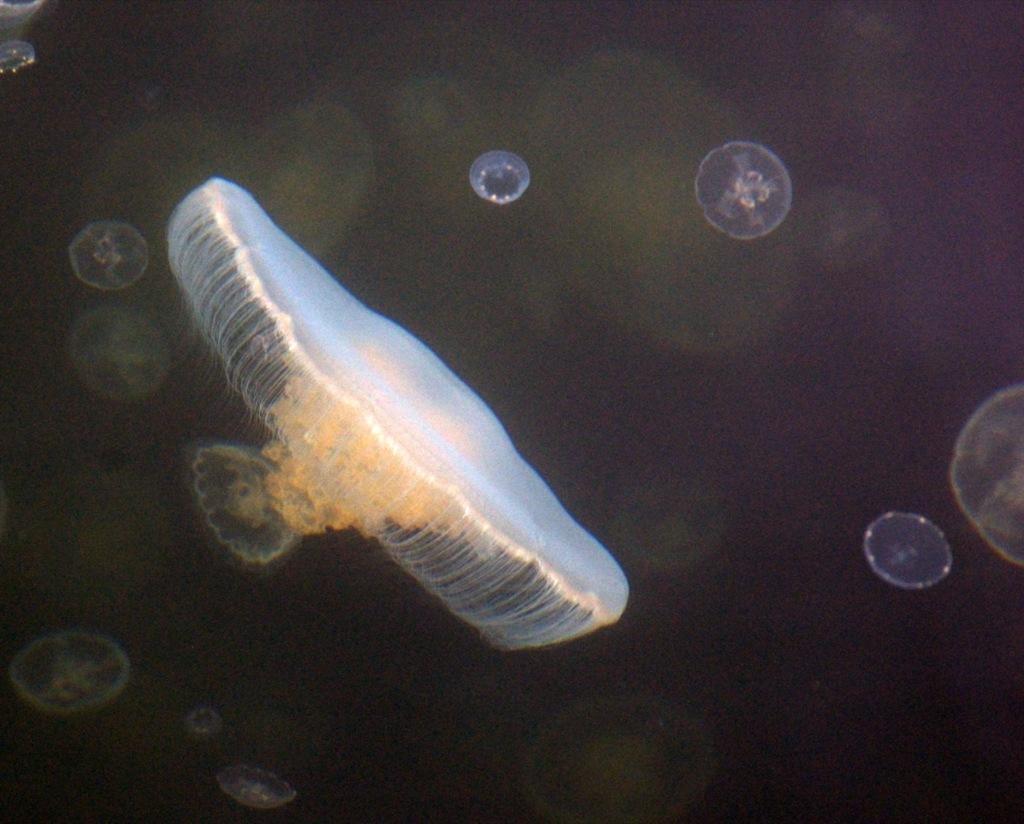Can you describe this image briefly? In this image, we can see there are jellyfish in the water. And the background is dark in color. 